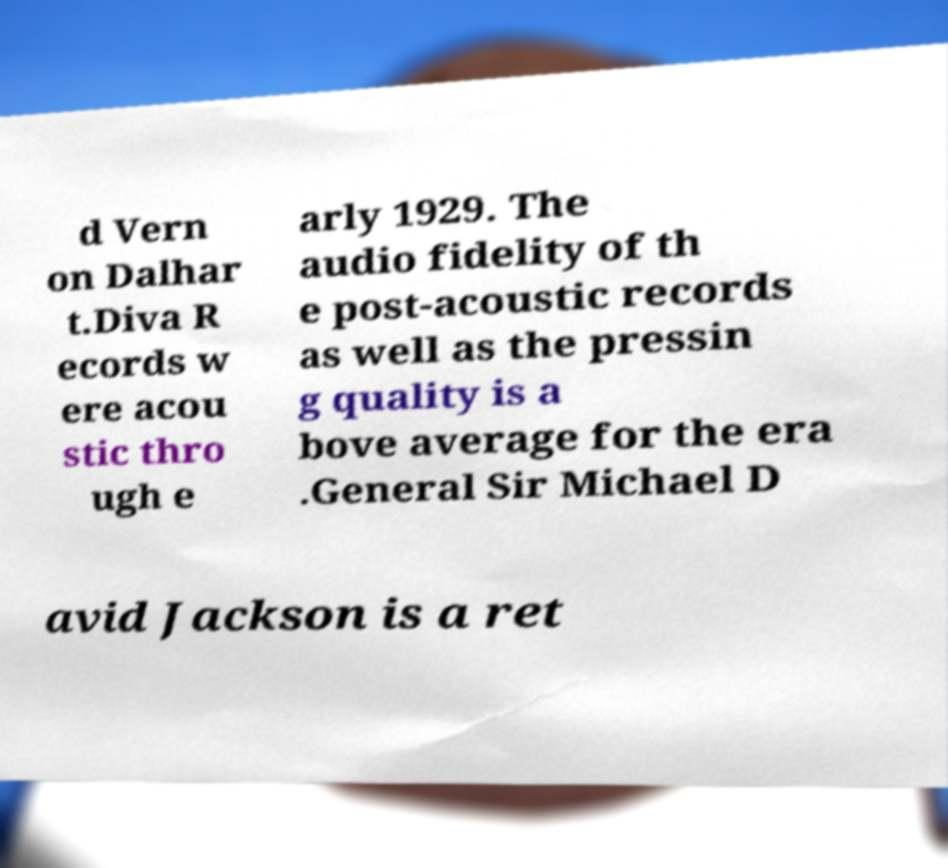I need the written content from this picture converted into text. Can you do that? d Vern on Dalhar t.Diva R ecords w ere acou stic thro ugh e arly 1929. The audio fidelity of th e post-acoustic records as well as the pressin g quality is a bove average for the era .General Sir Michael D avid Jackson is a ret 